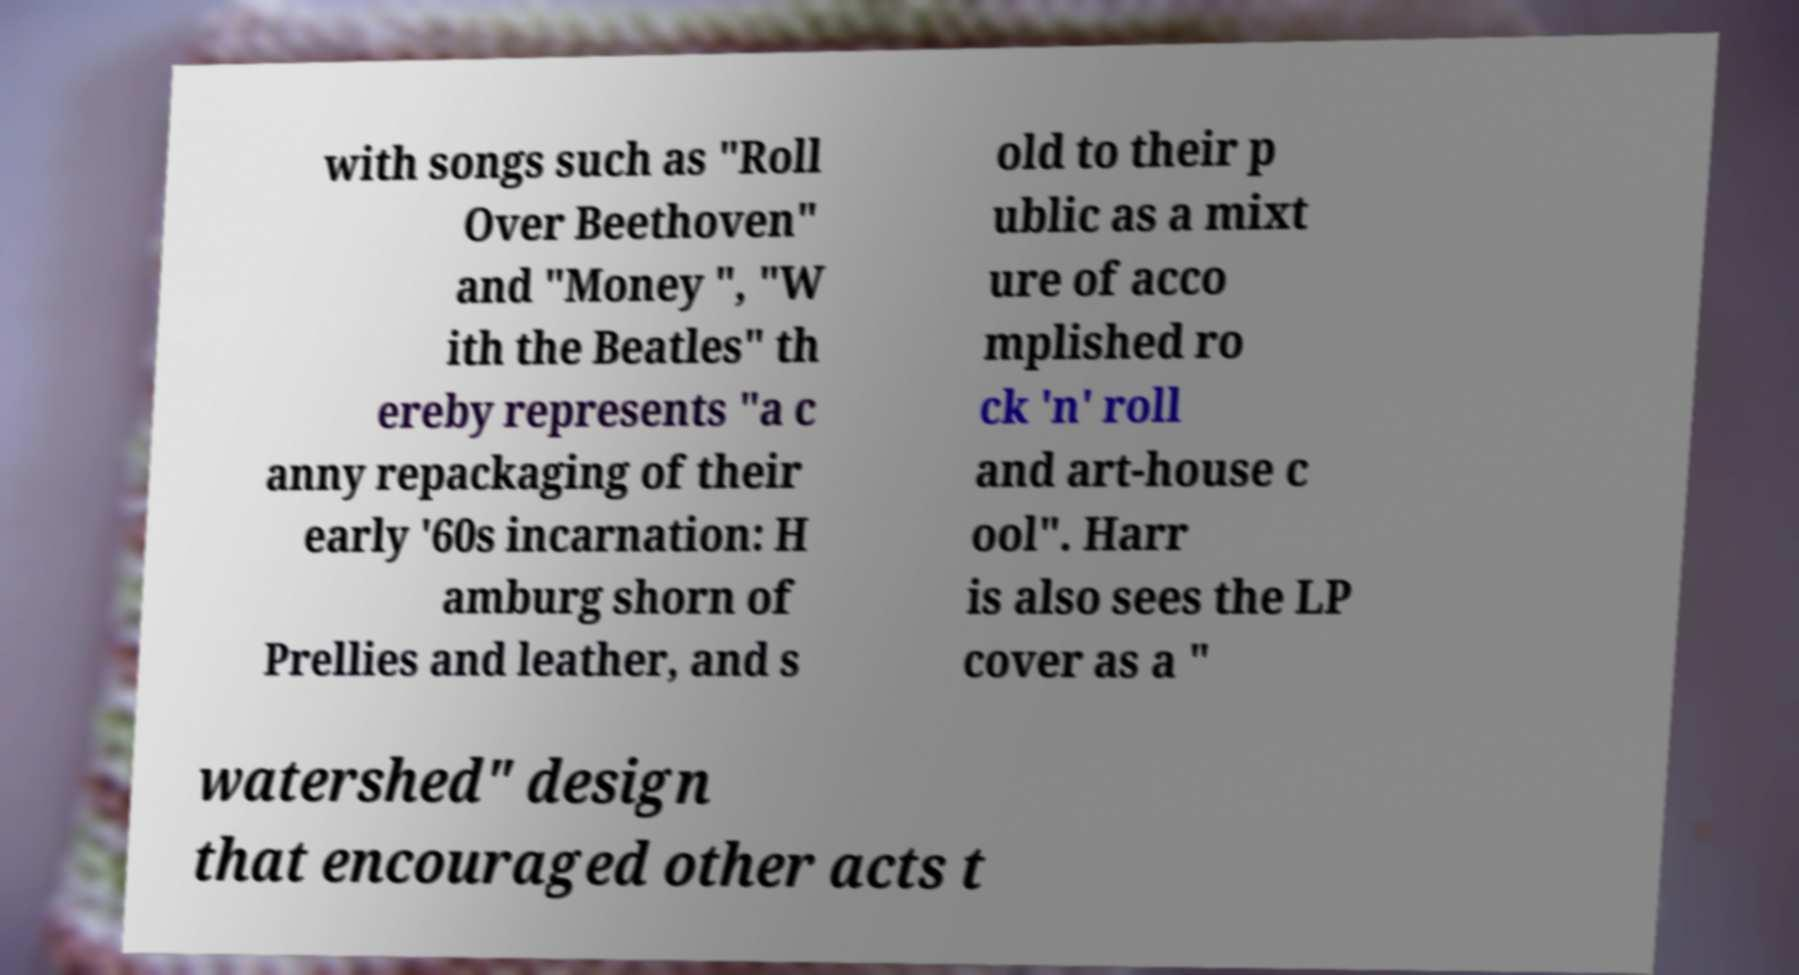I need the written content from this picture converted into text. Can you do that? with songs such as "Roll Over Beethoven" and "Money ", "W ith the Beatles" th ereby represents "a c anny repackaging of their early '60s incarnation: H amburg shorn of Prellies and leather, and s old to their p ublic as a mixt ure of acco mplished ro ck 'n' roll and art-house c ool". Harr is also sees the LP cover as a " watershed" design that encouraged other acts t 